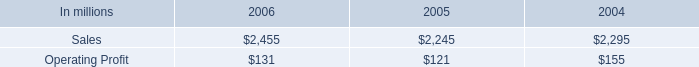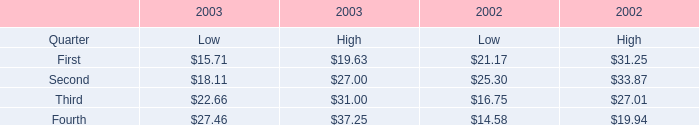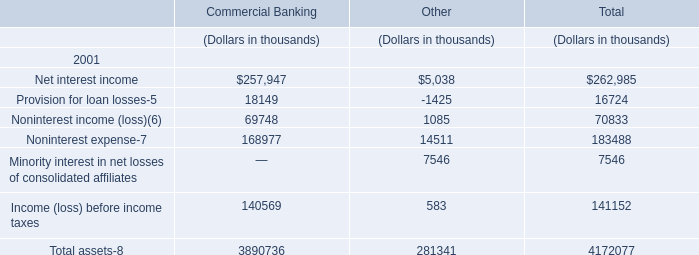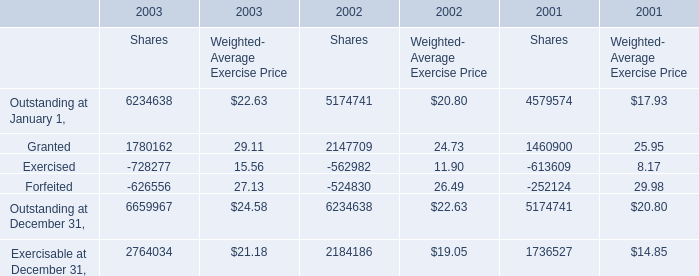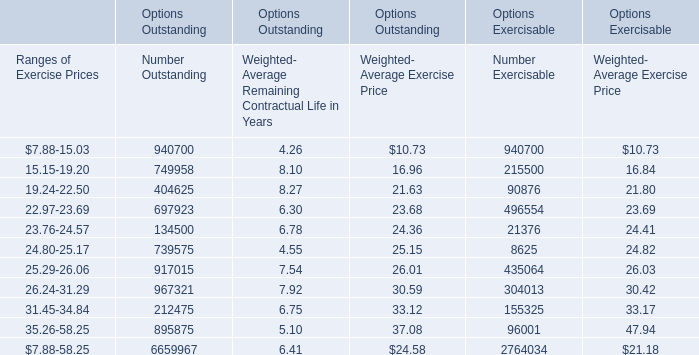in 2005 what percentage of consumer packaging sales were represented by foodservice net sales? 
Computations: (437 / 2245)
Answer: 0.19465. 